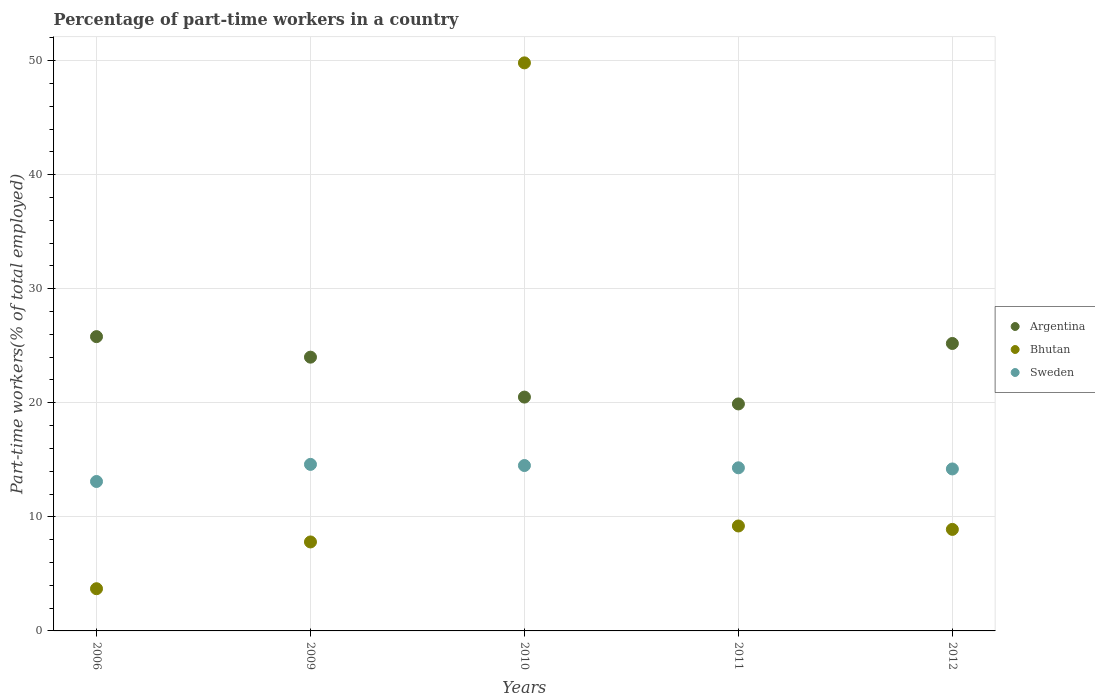How many different coloured dotlines are there?
Give a very brief answer. 3. What is the percentage of part-time workers in Sweden in 2009?
Offer a very short reply. 14.6. Across all years, what is the maximum percentage of part-time workers in Argentina?
Offer a terse response. 25.8. Across all years, what is the minimum percentage of part-time workers in Sweden?
Your answer should be compact. 13.1. In which year was the percentage of part-time workers in Argentina minimum?
Keep it short and to the point. 2011. What is the total percentage of part-time workers in Bhutan in the graph?
Your answer should be compact. 79.4. What is the difference between the percentage of part-time workers in Sweden in 2011 and that in 2012?
Provide a short and direct response. 0.1. What is the difference between the percentage of part-time workers in Argentina in 2011 and the percentage of part-time workers in Sweden in 2012?
Ensure brevity in your answer.  5.7. What is the average percentage of part-time workers in Argentina per year?
Your answer should be compact. 23.08. In the year 2011, what is the difference between the percentage of part-time workers in Sweden and percentage of part-time workers in Bhutan?
Offer a very short reply. 5.1. What is the ratio of the percentage of part-time workers in Sweden in 2006 to that in 2011?
Give a very brief answer. 0.92. What is the difference between the highest and the second highest percentage of part-time workers in Argentina?
Ensure brevity in your answer.  0.6. What is the difference between the highest and the lowest percentage of part-time workers in Argentina?
Your answer should be very brief. 5.9. Does the percentage of part-time workers in Sweden monotonically increase over the years?
Your response must be concise. No. How many dotlines are there?
Your answer should be very brief. 3. What is the difference between two consecutive major ticks on the Y-axis?
Make the answer very short. 10. Are the values on the major ticks of Y-axis written in scientific E-notation?
Make the answer very short. No. Does the graph contain any zero values?
Your answer should be very brief. No. Where does the legend appear in the graph?
Your response must be concise. Center right. What is the title of the graph?
Keep it short and to the point. Percentage of part-time workers in a country. Does "Azerbaijan" appear as one of the legend labels in the graph?
Make the answer very short. No. What is the label or title of the X-axis?
Offer a very short reply. Years. What is the label or title of the Y-axis?
Make the answer very short. Part-time workers(% of total employed). What is the Part-time workers(% of total employed) in Argentina in 2006?
Give a very brief answer. 25.8. What is the Part-time workers(% of total employed) in Bhutan in 2006?
Offer a terse response. 3.7. What is the Part-time workers(% of total employed) in Sweden in 2006?
Your response must be concise. 13.1. What is the Part-time workers(% of total employed) of Bhutan in 2009?
Make the answer very short. 7.8. What is the Part-time workers(% of total employed) in Sweden in 2009?
Your answer should be compact. 14.6. What is the Part-time workers(% of total employed) of Bhutan in 2010?
Offer a very short reply. 49.8. What is the Part-time workers(% of total employed) of Argentina in 2011?
Your answer should be compact. 19.9. What is the Part-time workers(% of total employed) of Bhutan in 2011?
Keep it short and to the point. 9.2. What is the Part-time workers(% of total employed) in Sweden in 2011?
Keep it short and to the point. 14.3. What is the Part-time workers(% of total employed) of Argentina in 2012?
Ensure brevity in your answer.  25.2. What is the Part-time workers(% of total employed) of Bhutan in 2012?
Ensure brevity in your answer.  8.9. What is the Part-time workers(% of total employed) of Sweden in 2012?
Your answer should be compact. 14.2. Across all years, what is the maximum Part-time workers(% of total employed) in Argentina?
Keep it short and to the point. 25.8. Across all years, what is the maximum Part-time workers(% of total employed) in Bhutan?
Your answer should be very brief. 49.8. Across all years, what is the maximum Part-time workers(% of total employed) of Sweden?
Provide a short and direct response. 14.6. Across all years, what is the minimum Part-time workers(% of total employed) of Argentina?
Your response must be concise. 19.9. Across all years, what is the minimum Part-time workers(% of total employed) in Bhutan?
Offer a very short reply. 3.7. Across all years, what is the minimum Part-time workers(% of total employed) in Sweden?
Provide a succinct answer. 13.1. What is the total Part-time workers(% of total employed) of Argentina in the graph?
Offer a terse response. 115.4. What is the total Part-time workers(% of total employed) in Bhutan in the graph?
Your answer should be very brief. 79.4. What is the total Part-time workers(% of total employed) in Sweden in the graph?
Make the answer very short. 70.7. What is the difference between the Part-time workers(% of total employed) in Bhutan in 2006 and that in 2010?
Your answer should be very brief. -46.1. What is the difference between the Part-time workers(% of total employed) in Sweden in 2006 and that in 2010?
Provide a succinct answer. -1.4. What is the difference between the Part-time workers(% of total employed) in Argentina in 2006 and that in 2011?
Ensure brevity in your answer.  5.9. What is the difference between the Part-time workers(% of total employed) in Sweden in 2006 and that in 2011?
Your answer should be very brief. -1.2. What is the difference between the Part-time workers(% of total employed) of Argentina in 2006 and that in 2012?
Give a very brief answer. 0.6. What is the difference between the Part-time workers(% of total employed) of Bhutan in 2006 and that in 2012?
Provide a short and direct response. -5.2. What is the difference between the Part-time workers(% of total employed) of Sweden in 2006 and that in 2012?
Your response must be concise. -1.1. What is the difference between the Part-time workers(% of total employed) of Argentina in 2009 and that in 2010?
Your answer should be very brief. 3.5. What is the difference between the Part-time workers(% of total employed) in Bhutan in 2009 and that in 2010?
Provide a short and direct response. -42. What is the difference between the Part-time workers(% of total employed) of Sweden in 2009 and that in 2010?
Provide a short and direct response. 0.1. What is the difference between the Part-time workers(% of total employed) of Bhutan in 2009 and that in 2011?
Offer a terse response. -1.4. What is the difference between the Part-time workers(% of total employed) of Bhutan in 2009 and that in 2012?
Keep it short and to the point. -1.1. What is the difference between the Part-time workers(% of total employed) in Sweden in 2009 and that in 2012?
Offer a terse response. 0.4. What is the difference between the Part-time workers(% of total employed) of Bhutan in 2010 and that in 2011?
Provide a succinct answer. 40.6. What is the difference between the Part-time workers(% of total employed) of Argentina in 2010 and that in 2012?
Offer a terse response. -4.7. What is the difference between the Part-time workers(% of total employed) in Bhutan in 2010 and that in 2012?
Your answer should be very brief. 40.9. What is the difference between the Part-time workers(% of total employed) of Argentina in 2011 and that in 2012?
Your answer should be very brief. -5.3. What is the difference between the Part-time workers(% of total employed) in Argentina in 2006 and the Part-time workers(% of total employed) in Bhutan in 2009?
Ensure brevity in your answer.  18. What is the difference between the Part-time workers(% of total employed) of Bhutan in 2006 and the Part-time workers(% of total employed) of Sweden in 2009?
Ensure brevity in your answer.  -10.9. What is the difference between the Part-time workers(% of total employed) in Argentina in 2006 and the Part-time workers(% of total employed) in Bhutan in 2010?
Your response must be concise. -24. What is the difference between the Part-time workers(% of total employed) in Argentina in 2006 and the Part-time workers(% of total employed) in Sweden in 2010?
Keep it short and to the point. 11.3. What is the difference between the Part-time workers(% of total employed) in Bhutan in 2006 and the Part-time workers(% of total employed) in Sweden in 2010?
Give a very brief answer. -10.8. What is the difference between the Part-time workers(% of total employed) in Argentina in 2006 and the Part-time workers(% of total employed) in Bhutan in 2012?
Keep it short and to the point. 16.9. What is the difference between the Part-time workers(% of total employed) in Bhutan in 2006 and the Part-time workers(% of total employed) in Sweden in 2012?
Give a very brief answer. -10.5. What is the difference between the Part-time workers(% of total employed) of Argentina in 2009 and the Part-time workers(% of total employed) of Bhutan in 2010?
Offer a very short reply. -25.8. What is the difference between the Part-time workers(% of total employed) of Argentina in 2009 and the Part-time workers(% of total employed) of Bhutan in 2011?
Your answer should be very brief. 14.8. What is the difference between the Part-time workers(% of total employed) in Argentina in 2009 and the Part-time workers(% of total employed) in Sweden in 2011?
Make the answer very short. 9.7. What is the difference between the Part-time workers(% of total employed) of Bhutan in 2009 and the Part-time workers(% of total employed) of Sweden in 2011?
Your response must be concise. -6.5. What is the difference between the Part-time workers(% of total employed) in Argentina in 2009 and the Part-time workers(% of total employed) in Sweden in 2012?
Give a very brief answer. 9.8. What is the difference between the Part-time workers(% of total employed) in Bhutan in 2009 and the Part-time workers(% of total employed) in Sweden in 2012?
Your answer should be compact. -6.4. What is the difference between the Part-time workers(% of total employed) of Argentina in 2010 and the Part-time workers(% of total employed) of Sweden in 2011?
Your answer should be very brief. 6.2. What is the difference between the Part-time workers(% of total employed) in Bhutan in 2010 and the Part-time workers(% of total employed) in Sweden in 2011?
Provide a short and direct response. 35.5. What is the difference between the Part-time workers(% of total employed) in Argentina in 2010 and the Part-time workers(% of total employed) in Bhutan in 2012?
Keep it short and to the point. 11.6. What is the difference between the Part-time workers(% of total employed) in Argentina in 2010 and the Part-time workers(% of total employed) in Sweden in 2012?
Your answer should be compact. 6.3. What is the difference between the Part-time workers(% of total employed) of Bhutan in 2010 and the Part-time workers(% of total employed) of Sweden in 2012?
Offer a terse response. 35.6. What is the difference between the Part-time workers(% of total employed) in Argentina in 2011 and the Part-time workers(% of total employed) in Sweden in 2012?
Offer a very short reply. 5.7. What is the average Part-time workers(% of total employed) of Argentina per year?
Your response must be concise. 23.08. What is the average Part-time workers(% of total employed) in Bhutan per year?
Provide a succinct answer. 15.88. What is the average Part-time workers(% of total employed) of Sweden per year?
Offer a terse response. 14.14. In the year 2006, what is the difference between the Part-time workers(% of total employed) of Argentina and Part-time workers(% of total employed) of Bhutan?
Your answer should be very brief. 22.1. In the year 2006, what is the difference between the Part-time workers(% of total employed) of Argentina and Part-time workers(% of total employed) of Sweden?
Provide a succinct answer. 12.7. In the year 2006, what is the difference between the Part-time workers(% of total employed) of Bhutan and Part-time workers(% of total employed) of Sweden?
Offer a very short reply. -9.4. In the year 2009, what is the difference between the Part-time workers(% of total employed) of Argentina and Part-time workers(% of total employed) of Bhutan?
Offer a terse response. 16.2. In the year 2009, what is the difference between the Part-time workers(% of total employed) of Argentina and Part-time workers(% of total employed) of Sweden?
Your answer should be very brief. 9.4. In the year 2010, what is the difference between the Part-time workers(% of total employed) in Argentina and Part-time workers(% of total employed) in Bhutan?
Make the answer very short. -29.3. In the year 2010, what is the difference between the Part-time workers(% of total employed) of Argentina and Part-time workers(% of total employed) of Sweden?
Keep it short and to the point. 6. In the year 2010, what is the difference between the Part-time workers(% of total employed) of Bhutan and Part-time workers(% of total employed) of Sweden?
Your answer should be compact. 35.3. In the year 2011, what is the difference between the Part-time workers(% of total employed) in Argentina and Part-time workers(% of total employed) in Sweden?
Offer a terse response. 5.6. In the year 2011, what is the difference between the Part-time workers(% of total employed) of Bhutan and Part-time workers(% of total employed) of Sweden?
Give a very brief answer. -5.1. In the year 2012, what is the difference between the Part-time workers(% of total employed) of Argentina and Part-time workers(% of total employed) of Bhutan?
Your answer should be very brief. 16.3. What is the ratio of the Part-time workers(% of total employed) of Argentina in 2006 to that in 2009?
Your answer should be very brief. 1.07. What is the ratio of the Part-time workers(% of total employed) of Bhutan in 2006 to that in 2009?
Ensure brevity in your answer.  0.47. What is the ratio of the Part-time workers(% of total employed) of Sweden in 2006 to that in 2009?
Offer a very short reply. 0.9. What is the ratio of the Part-time workers(% of total employed) in Argentina in 2006 to that in 2010?
Your response must be concise. 1.26. What is the ratio of the Part-time workers(% of total employed) of Bhutan in 2006 to that in 2010?
Make the answer very short. 0.07. What is the ratio of the Part-time workers(% of total employed) in Sweden in 2006 to that in 2010?
Offer a very short reply. 0.9. What is the ratio of the Part-time workers(% of total employed) of Argentina in 2006 to that in 2011?
Offer a very short reply. 1.3. What is the ratio of the Part-time workers(% of total employed) in Bhutan in 2006 to that in 2011?
Your answer should be compact. 0.4. What is the ratio of the Part-time workers(% of total employed) of Sweden in 2006 to that in 2011?
Your answer should be very brief. 0.92. What is the ratio of the Part-time workers(% of total employed) in Argentina in 2006 to that in 2012?
Offer a very short reply. 1.02. What is the ratio of the Part-time workers(% of total employed) of Bhutan in 2006 to that in 2012?
Ensure brevity in your answer.  0.42. What is the ratio of the Part-time workers(% of total employed) in Sweden in 2006 to that in 2012?
Your answer should be compact. 0.92. What is the ratio of the Part-time workers(% of total employed) of Argentina in 2009 to that in 2010?
Give a very brief answer. 1.17. What is the ratio of the Part-time workers(% of total employed) of Bhutan in 2009 to that in 2010?
Offer a very short reply. 0.16. What is the ratio of the Part-time workers(% of total employed) in Sweden in 2009 to that in 2010?
Your answer should be very brief. 1.01. What is the ratio of the Part-time workers(% of total employed) in Argentina in 2009 to that in 2011?
Offer a terse response. 1.21. What is the ratio of the Part-time workers(% of total employed) of Bhutan in 2009 to that in 2011?
Offer a terse response. 0.85. What is the ratio of the Part-time workers(% of total employed) of Sweden in 2009 to that in 2011?
Ensure brevity in your answer.  1.02. What is the ratio of the Part-time workers(% of total employed) in Bhutan in 2009 to that in 2012?
Keep it short and to the point. 0.88. What is the ratio of the Part-time workers(% of total employed) in Sweden in 2009 to that in 2012?
Your answer should be very brief. 1.03. What is the ratio of the Part-time workers(% of total employed) in Argentina in 2010 to that in 2011?
Your response must be concise. 1.03. What is the ratio of the Part-time workers(% of total employed) in Bhutan in 2010 to that in 2011?
Make the answer very short. 5.41. What is the ratio of the Part-time workers(% of total employed) in Argentina in 2010 to that in 2012?
Keep it short and to the point. 0.81. What is the ratio of the Part-time workers(% of total employed) in Bhutan in 2010 to that in 2012?
Provide a short and direct response. 5.6. What is the ratio of the Part-time workers(% of total employed) of Sweden in 2010 to that in 2012?
Make the answer very short. 1.02. What is the ratio of the Part-time workers(% of total employed) of Argentina in 2011 to that in 2012?
Provide a succinct answer. 0.79. What is the ratio of the Part-time workers(% of total employed) of Bhutan in 2011 to that in 2012?
Your response must be concise. 1.03. What is the ratio of the Part-time workers(% of total employed) of Sweden in 2011 to that in 2012?
Offer a very short reply. 1.01. What is the difference between the highest and the second highest Part-time workers(% of total employed) in Bhutan?
Offer a terse response. 40.6. What is the difference between the highest and the lowest Part-time workers(% of total employed) in Argentina?
Make the answer very short. 5.9. What is the difference between the highest and the lowest Part-time workers(% of total employed) of Bhutan?
Ensure brevity in your answer.  46.1. 